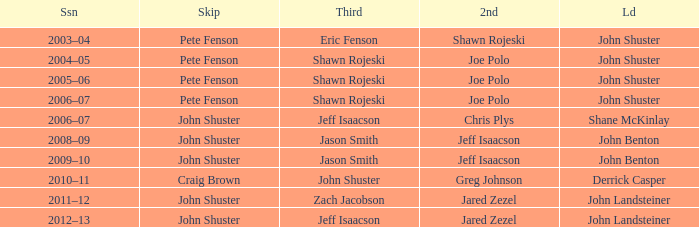Who was the lead with John Shuster as skip in the season of 2009–10? John Benton. 